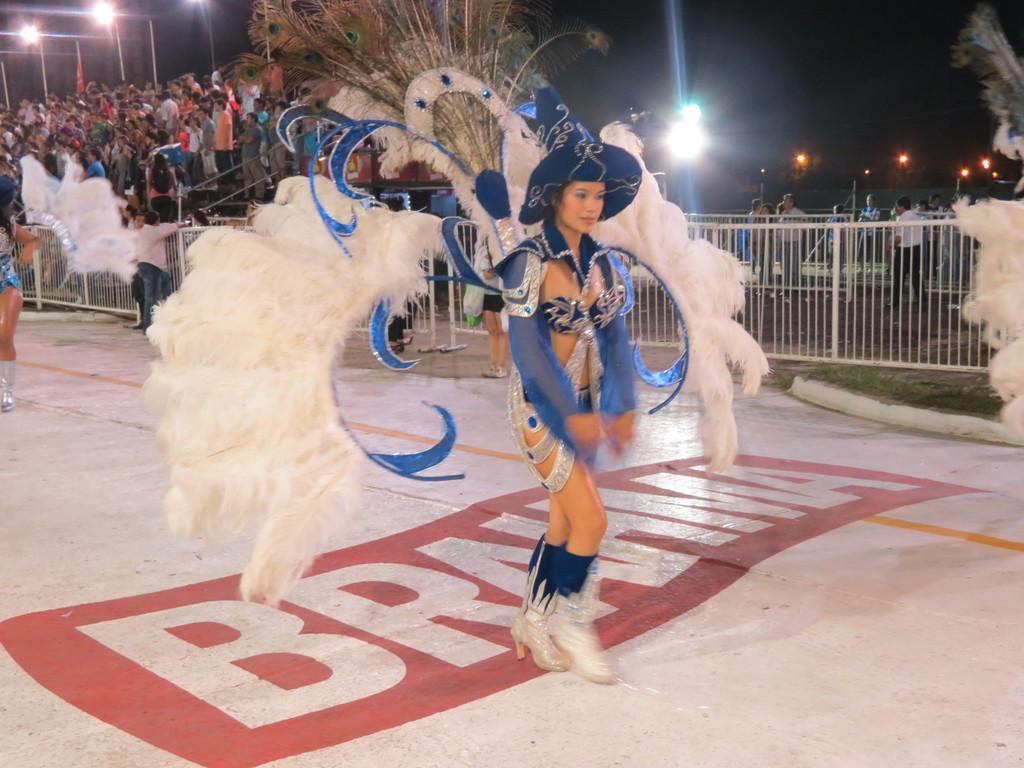Could you give a brief overview of what you see in this image? In this image, we can see few people. Few are wearing different costumes. Background we can see grills, stairs, poles, lights and dark view. 